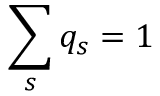Convert formula to latex. <formula><loc_0><loc_0><loc_500><loc_500>\sum _ { s } q _ { s } = 1</formula> 